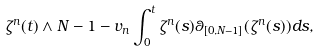Convert formula to latex. <formula><loc_0><loc_0><loc_500><loc_500>\zeta ^ { n } ( t ) \land N - 1 - v _ { n } \int _ { 0 } ^ { t } \zeta ^ { n } ( s ) \theta _ { [ 0 , N - 1 ] } ( \zeta ^ { n } ( s ) ) d s ,</formula> 